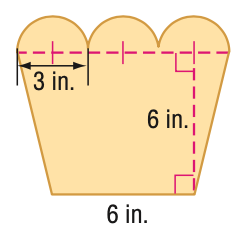Answer the mathemtical geometry problem and directly provide the correct option letter.
Question: Find the area of the figure. Round to the nearest tenth if necessary.
Choices: A: 55.6 B: 66.2 C: 100.6 D: 111.2 A 